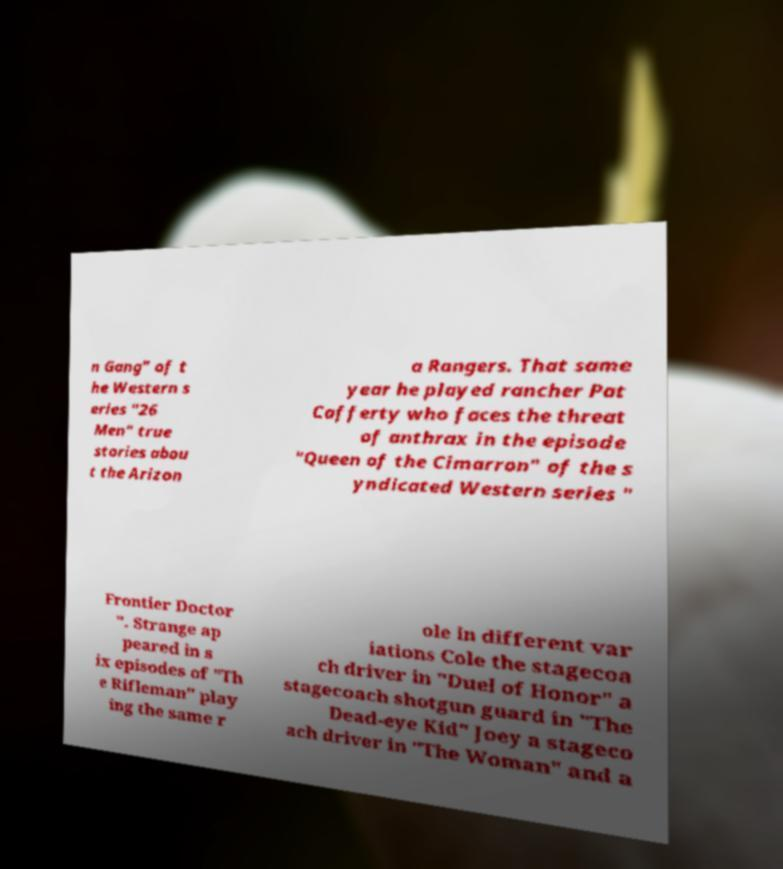I need the written content from this picture converted into text. Can you do that? n Gang" of t he Western s eries "26 Men" true stories abou t the Arizon a Rangers. That same year he played rancher Pat Cafferty who faces the threat of anthrax in the episode "Queen of the Cimarron" of the s yndicated Western series " Frontier Doctor ". Strange ap peared in s ix episodes of "Th e Rifleman" play ing the same r ole in different var iations Cole the stagecoa ch driver in "Duel of Honor" a stagecoach shotgun guard in "The Dead-eye Kid" Joey a stageco ach driver in "The Woman" and a 